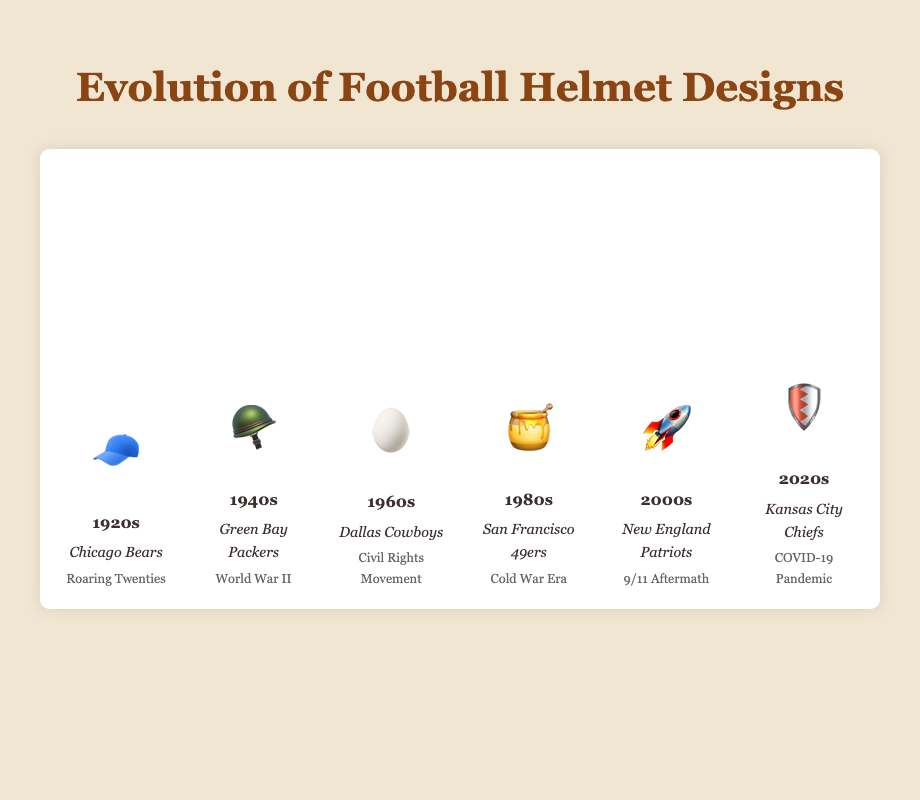What is the title of the chart? The title is displayed at the top of the chart. It reads "Evolution of Football Helmet Designs."
Answer: Evolution of Football Helmet Designs Which decade features a helmet design represented by 🧢? The helmet design represented by 🧢 is shown in the bar labeled "1920s."
Answer: 1920s How many notable teams are mentioned in the chart? Each decade lists one notable team, and there are six decades shown. Therefore, the chart mentions six notable teams.
Answer: 6 Which decade has the highest safety improvement score? The height of the safety improvement bar increases across decades, with the 2020s having the tallest bar at 100%.
Answer: 2020s Compare the safety improvement between the 1940s and the 1980s. Which is higher? The safety improvement bar for the 1940s is at 33.33%, while the bar for the 1980s is at 66.67%. The 1980s has a higher safety improvement.
Answer: 1980s What helmet design is shown for the 1980s and which historical event is associated with it? The helmet design for the 1980s is represented by 🍯, and the associated historical event is the Cold War Era.
Answer: 🍯 and Cold War Era If you look at the helmet design changes, which decade saw the introduction of a design represented by 🛡️? The design represented by 🛡️ is introduced in the 2020s according to the chart.
Answer: 2020s Which notable team is associated with the Civil Rights Movement? The Civil Rights Movement is mentioned directly under the decade labelled "1960s," which lists the Dallas Cowboys as the notable team.
Answer: Dallas Cowboys What is the average safety improvement percentage across all decades? Add the safety percentages for all decades and divide by the number of decades: (16.67% + 33.33% + 50% + 66.67% + 83.33% + 100%) / 6 = 350% / 6 = 58.33%
Answer: 58.33% Explain the progression of helmet designs from 1920s to 2020s using emojis. The chart shows helmet designs evolving as follows: 1920s 🧢, 1940s 🪖, 1960s 🥚, 1980s 🍯, 2000s 🚀, and 2020s 🛡️. The emojis depict a progression from simpler caps to advanced helmets with modern designs.
Answer: 🧢 → 🪖 → 🥚 → 🍯 → 🚀 → 🛡️ 